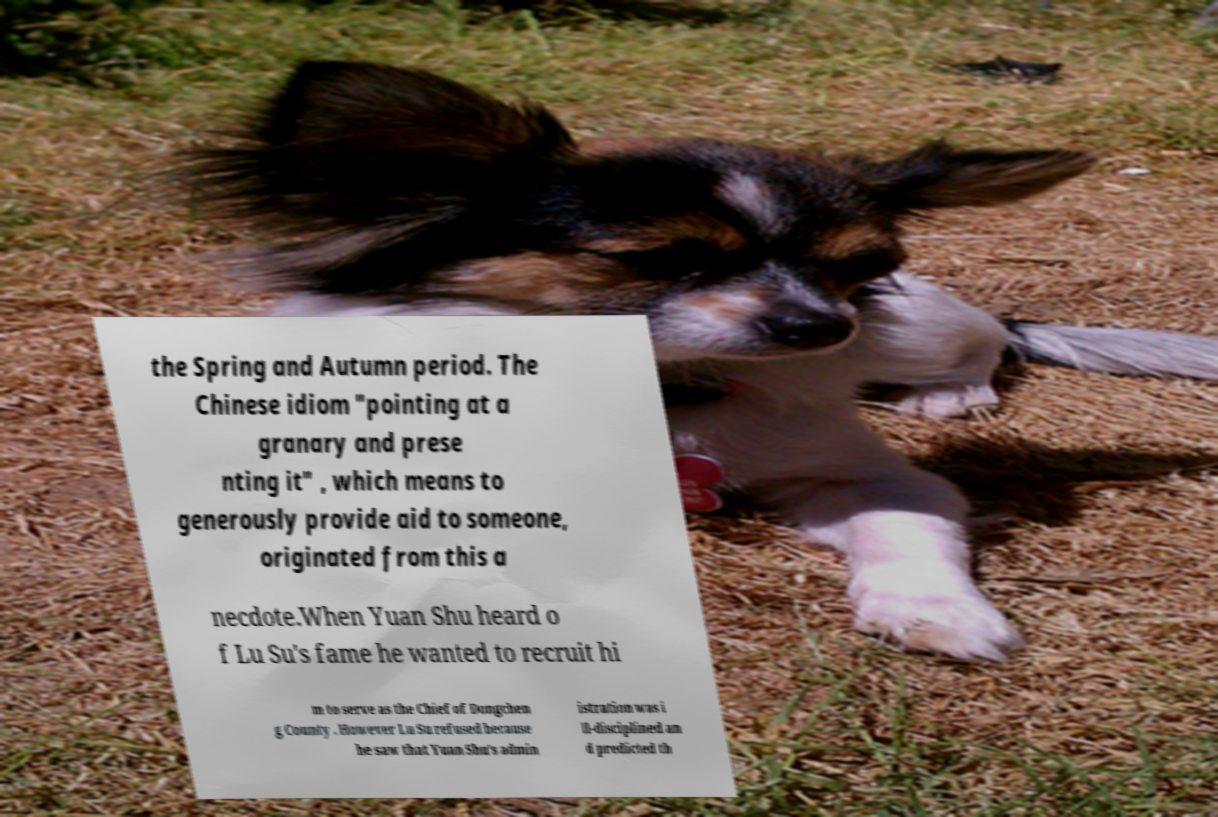Please read and relay the text visible in this image. What does it say? the Spring and Autumn period. The Chinese idiom "pointing at a granary and prese nting it" , which means to generously provide aid to someone, originated from this a necdote.When Yuan Shu heard o f Lu Su's fame he wanted to recruit hi m to serve as the Chief of Dongchen g County . However Lu Su refused because he saw that Yuan Shu's admin istration was i ll-disciplined an d predicted th 